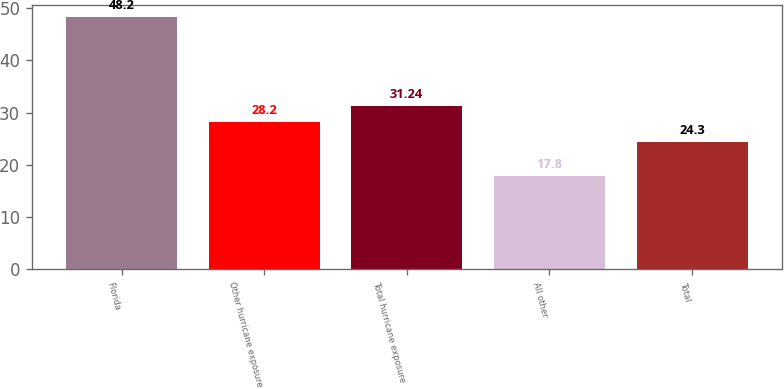Convert chart. <chart><loc_0><loc_0><loc_500><loc_500><bar_chart><fcel>Florida<fcel>Other hurricane exposure<fcel>Total hurricane exposure<fcel>All other<fcel>Total<nl><fcel>48.2<fcel>28.2<fcel>31.24<fcel>17.8<fcel>24.3<nl></chart> 